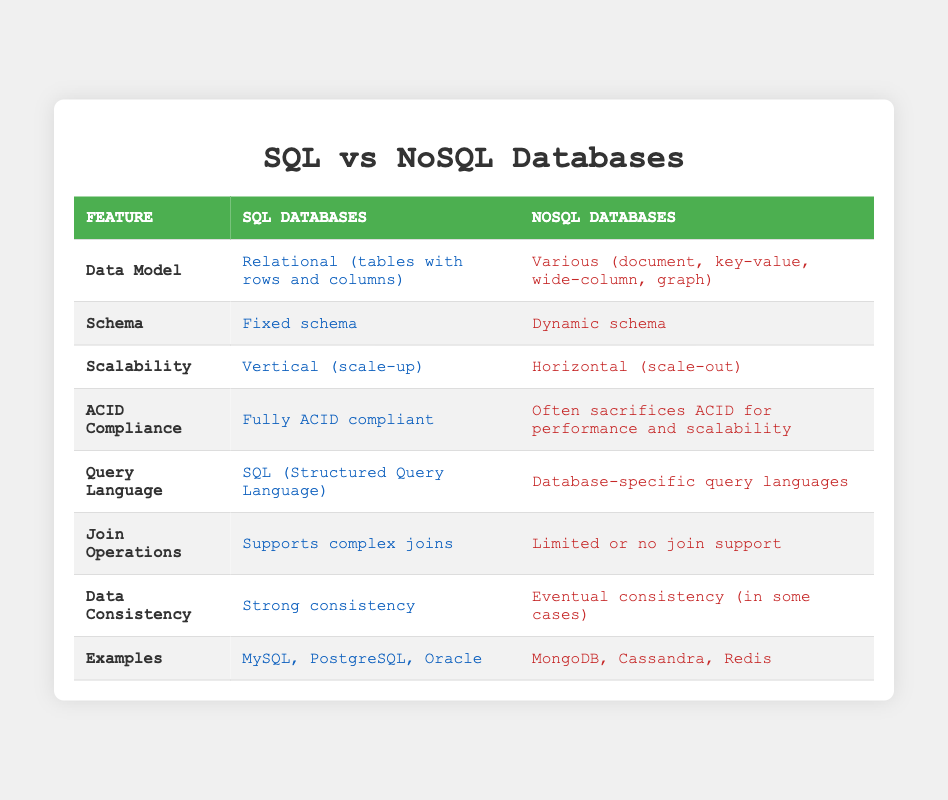What is the data model used by SQL databases? The SQL databases use a relational data model, which is characterized by tables consisting of rows and columns. This is directly stated in the table under the "Data Model" row for SQL Databases.
Answer: Relational (tables with rows and columns) What type of schema do NoSQL databases utilize? The table specifies that NoSQL databases implement a dynamic schema, as indicated in the "Schema" row for NoSQL Databases.
Answer: Dynamic schema Are SQL databases fully ACID compliant? According to the table, SQL databases are described as "fully ACID compliant," confirming that this statement is true.
Answer: Yes Which database type supports complex join operations? The table indicates that SQL databases support complex joins, while NoSQL databases typically have limited or no join support. Therefore, the answer is SQL databases.
Answer: SQL Databases What is the difference in scalability between SQL and NoSQL databases? The table outlines that SQL databases scale vertically (scale-up) while NoSQL databases scale horizontally (scale-out), highlighting the fundamental difference in their scalability approach.
Answer: SQL: vertical (scale-up), NoSQL: horizontal (scale-out) Which databases are examples of NoSQL databases? The table presents MongoDB, Cassandra, and Redis as examples of NoSQL databases under the "Examples" row, making it clear which databases fall into this category.
Answer: MongoDB, Cassandra, Redis How does the data consistency in SQL databases compare to NoSQL databases? The table shows that SQL databases offer strong consistency, whereas NoSQL databases often provide eventual consistency. This indicates that SQL databases prioritize data consistency more than NoSQL databases.
Answer: SQL: strong consistency, NoSQL: eventual consistency Do NoSQL databases generally have a fixed schema? The table clearly states that NoSQL databases have a dynamic schema, which means this statement is false.
Answer: No What are the implications of ACID compliance in databases? SQL databases are fully ACID compliant, which supports transactions and ensures data integrity, while NoSQL databases may sacrifice ACID for performance and scalability. Hence, SQL databases prioritize reliability over potential speed.
Answer: SQL adheres to ACID, NoSQL often sacrifices it 